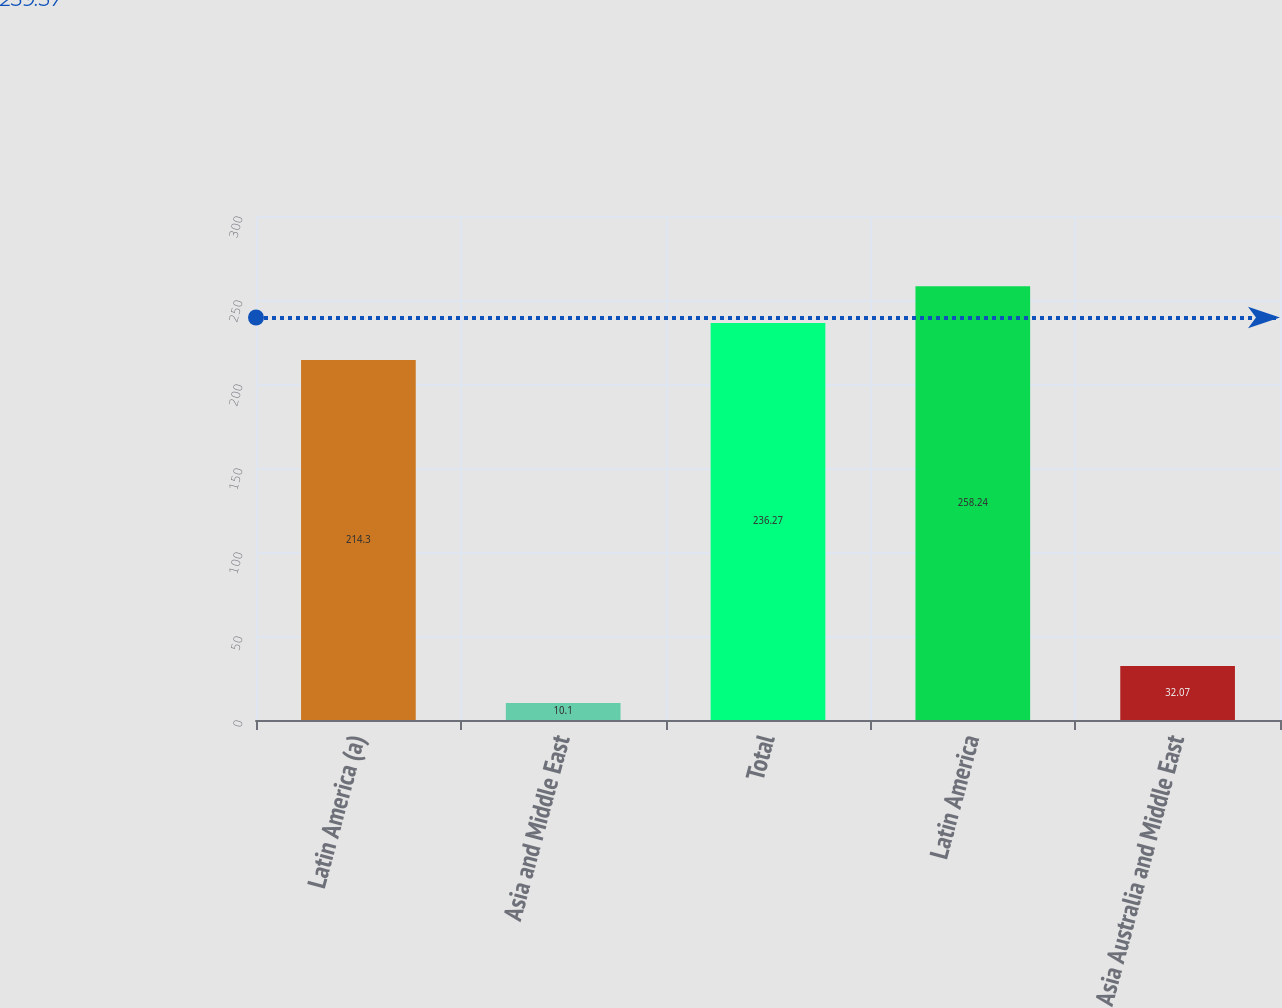<chart> <loc_0><loc_0><loc_500><loc_500><bar_chart><fcel>Latin America (a)<fcel>Asia and Middle East<fcel>Total<fcel>Latin America<fcel>Asia Australia and Middle East<nl><fcel>214.3<fcel>10.1<fcel>236.27<fcel>258.24<fcel>32.07<nl></chart> 